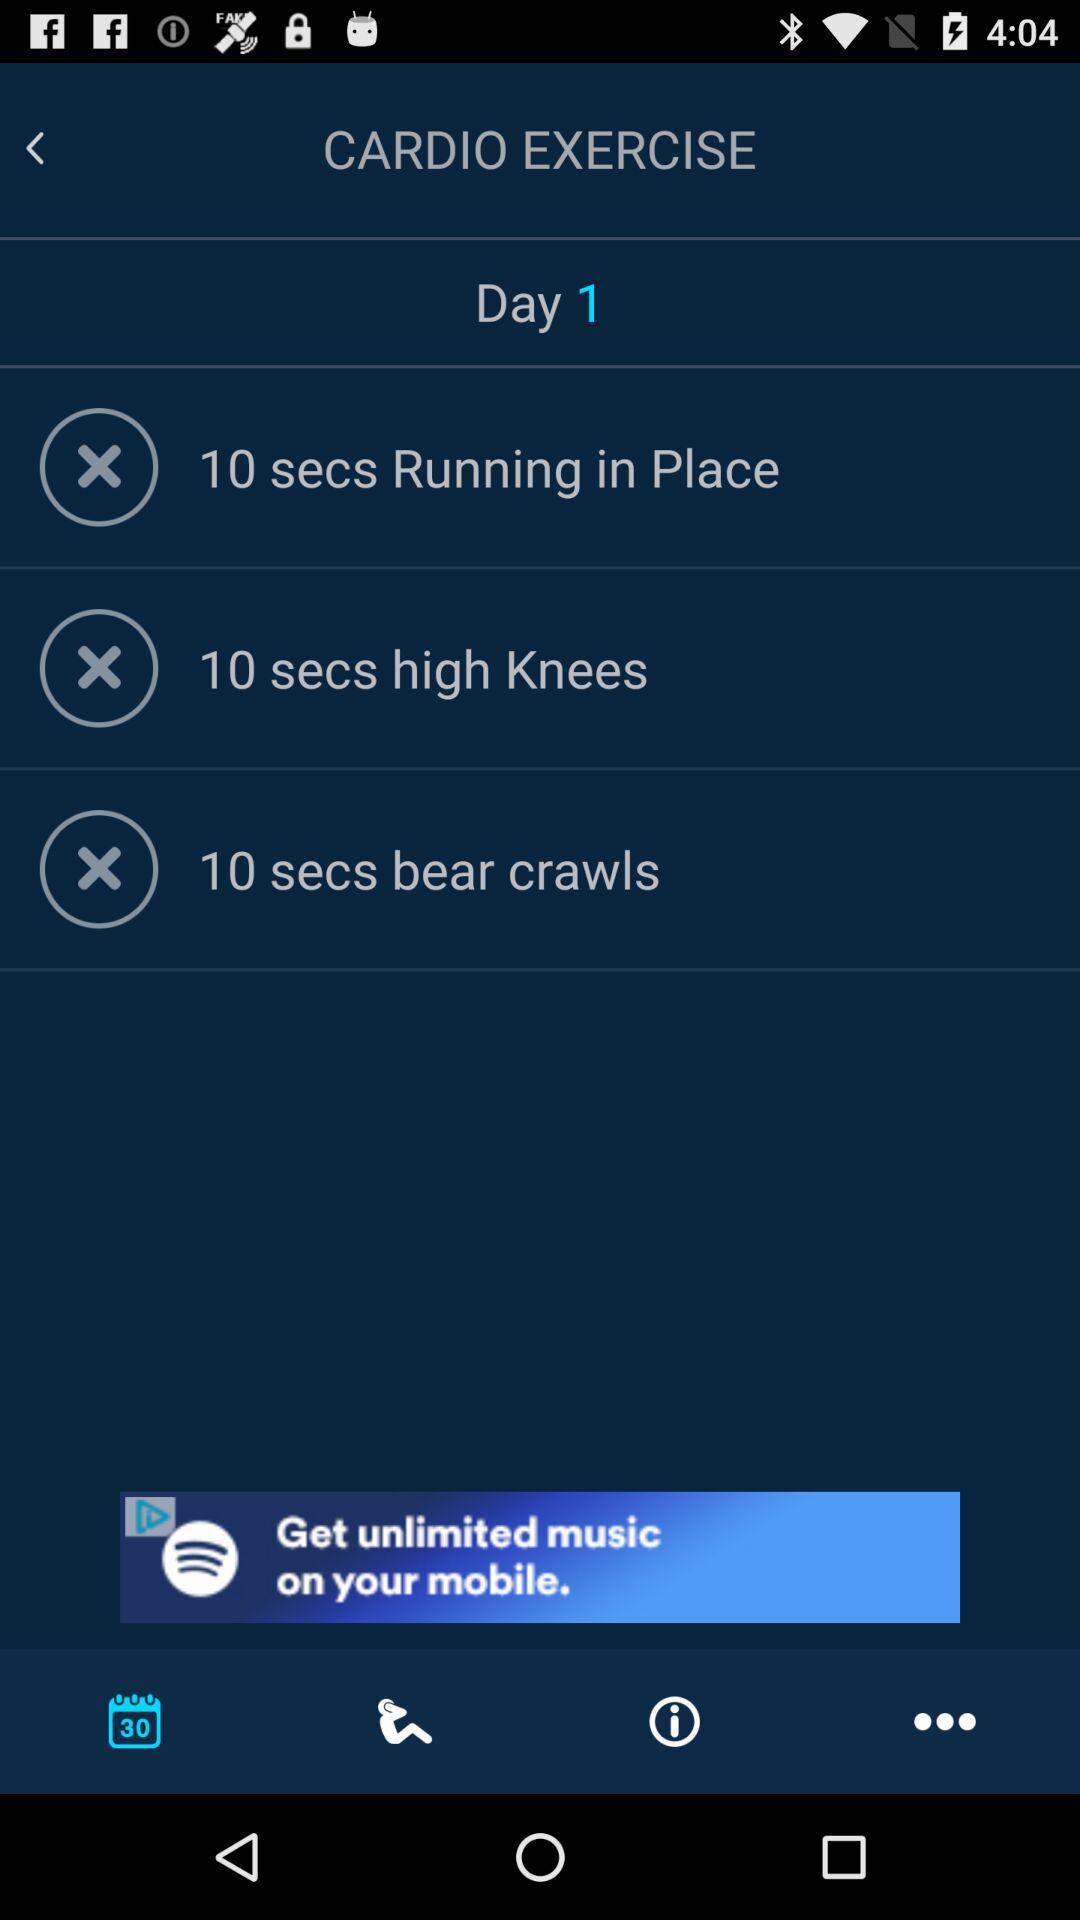How many seconds of exercise are there in this workout?
Answer the question using a single word or phrase. 30 